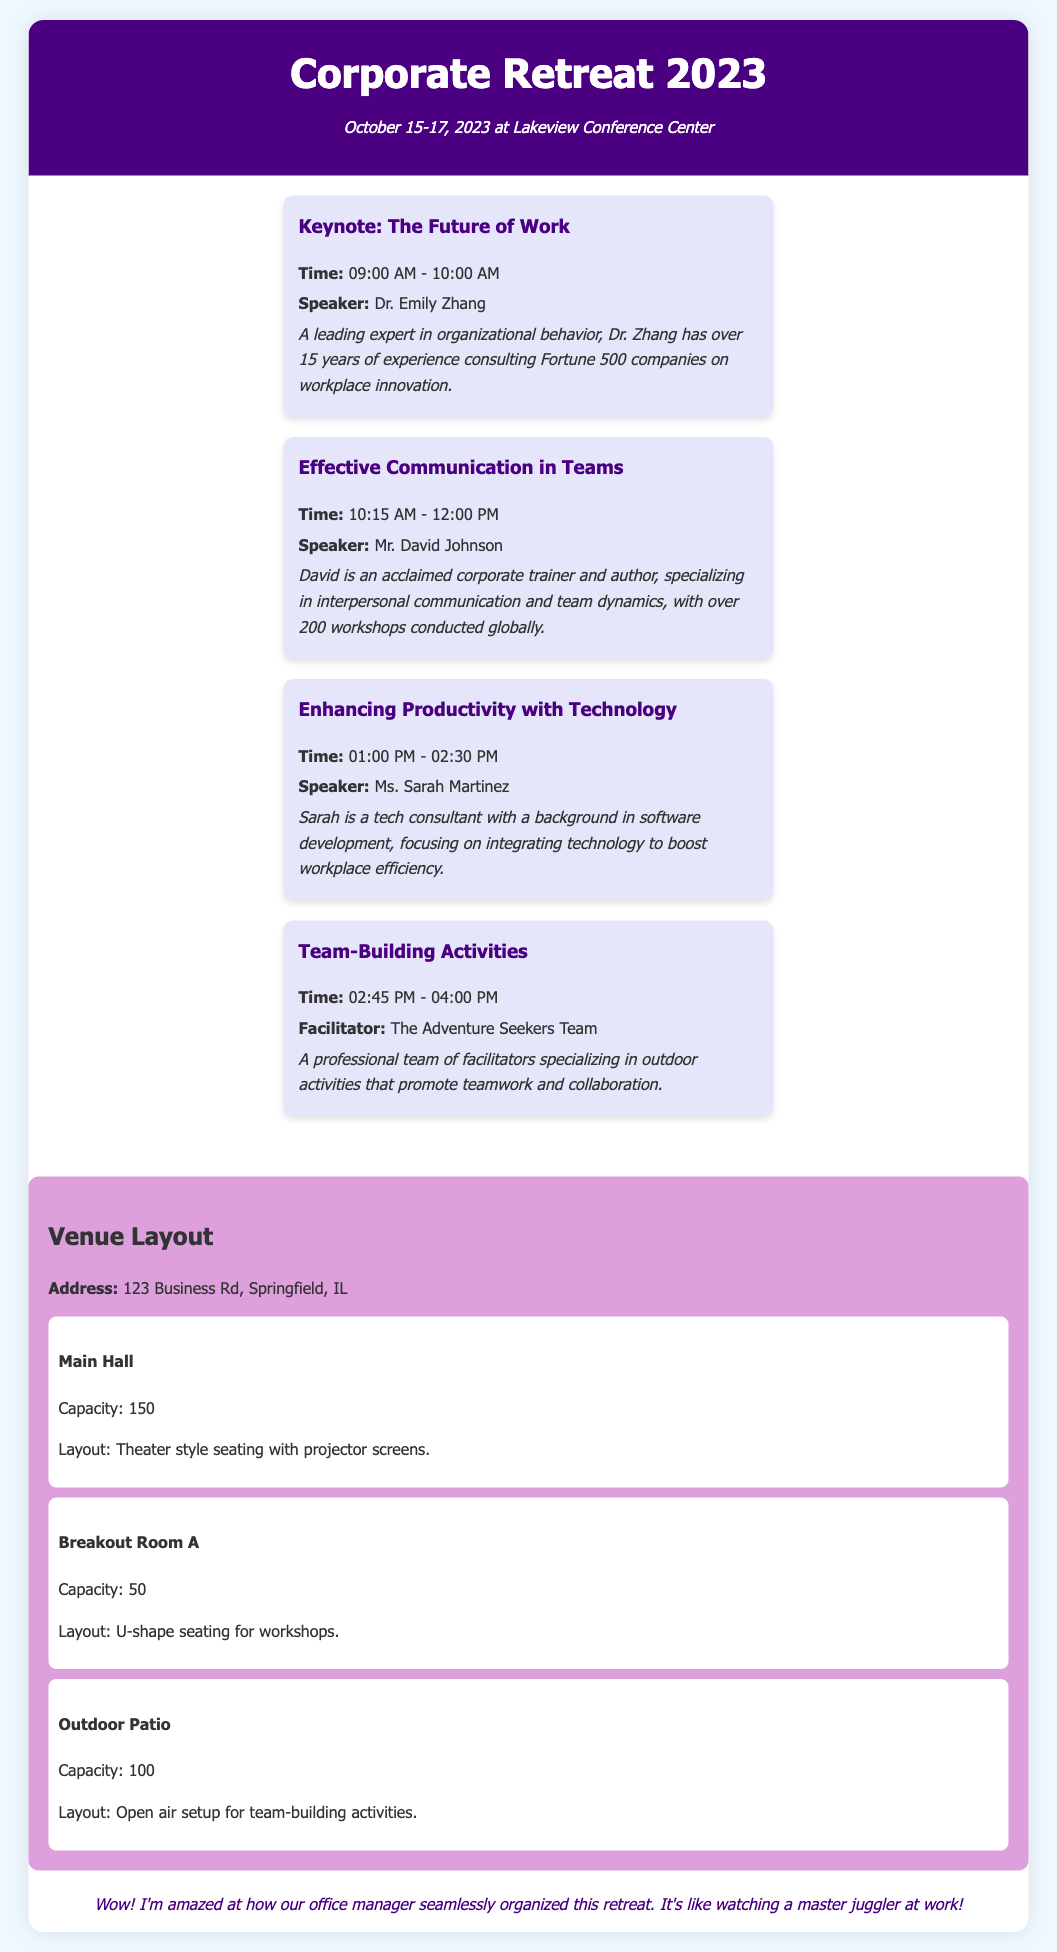What are the dates of the retreat? The dates mentioned for the corporate retreat are October 15-17, 2023.
Answer: October 15-17, 2023 Who is the speaker for the Keynote session? The document lists Dr. Emily Zhang as the speaker for the Keynote session titled "The Future of Work."
Answer: Dr. Emily Zhang What time does the session on Effective Communication in Teams start? The start time for the session on Effective Communication in Teams is given as 10:15 AM.
Answer: 10:15 AM How many sessions are scheduled for the corporate retreat? There are four sessions listed in the document for the corporate retreat, each with distinct topics and speakers.
Answer: Four What is the capacity of the Main Hall? The Main Hall's capacity is provided as 150 in the venue layout section of the document.
Answer: 150 What type of seating is arranged in Breakout Room A? The document specifies that Breakout Room A has U-shape seating for workshops.
Answer: U-shape Which team is facilitating the Team-Building Activities? The document identifies The Adventure Seekers Team as the facilitators for the Team-Building Activities.
Answer: The Adventure Seekers Team What is the layout for the Outdoor Patio? The layout for the Outdoor Patio is described as an open-air setup for team-building activities.
Answer: Open air setup What is the address of the venue? The address of the Lakeview Conference Center is listed as 123 Business Rd, Springfield, IL.
Answer: 123 Business Rd, Springfield, IL 